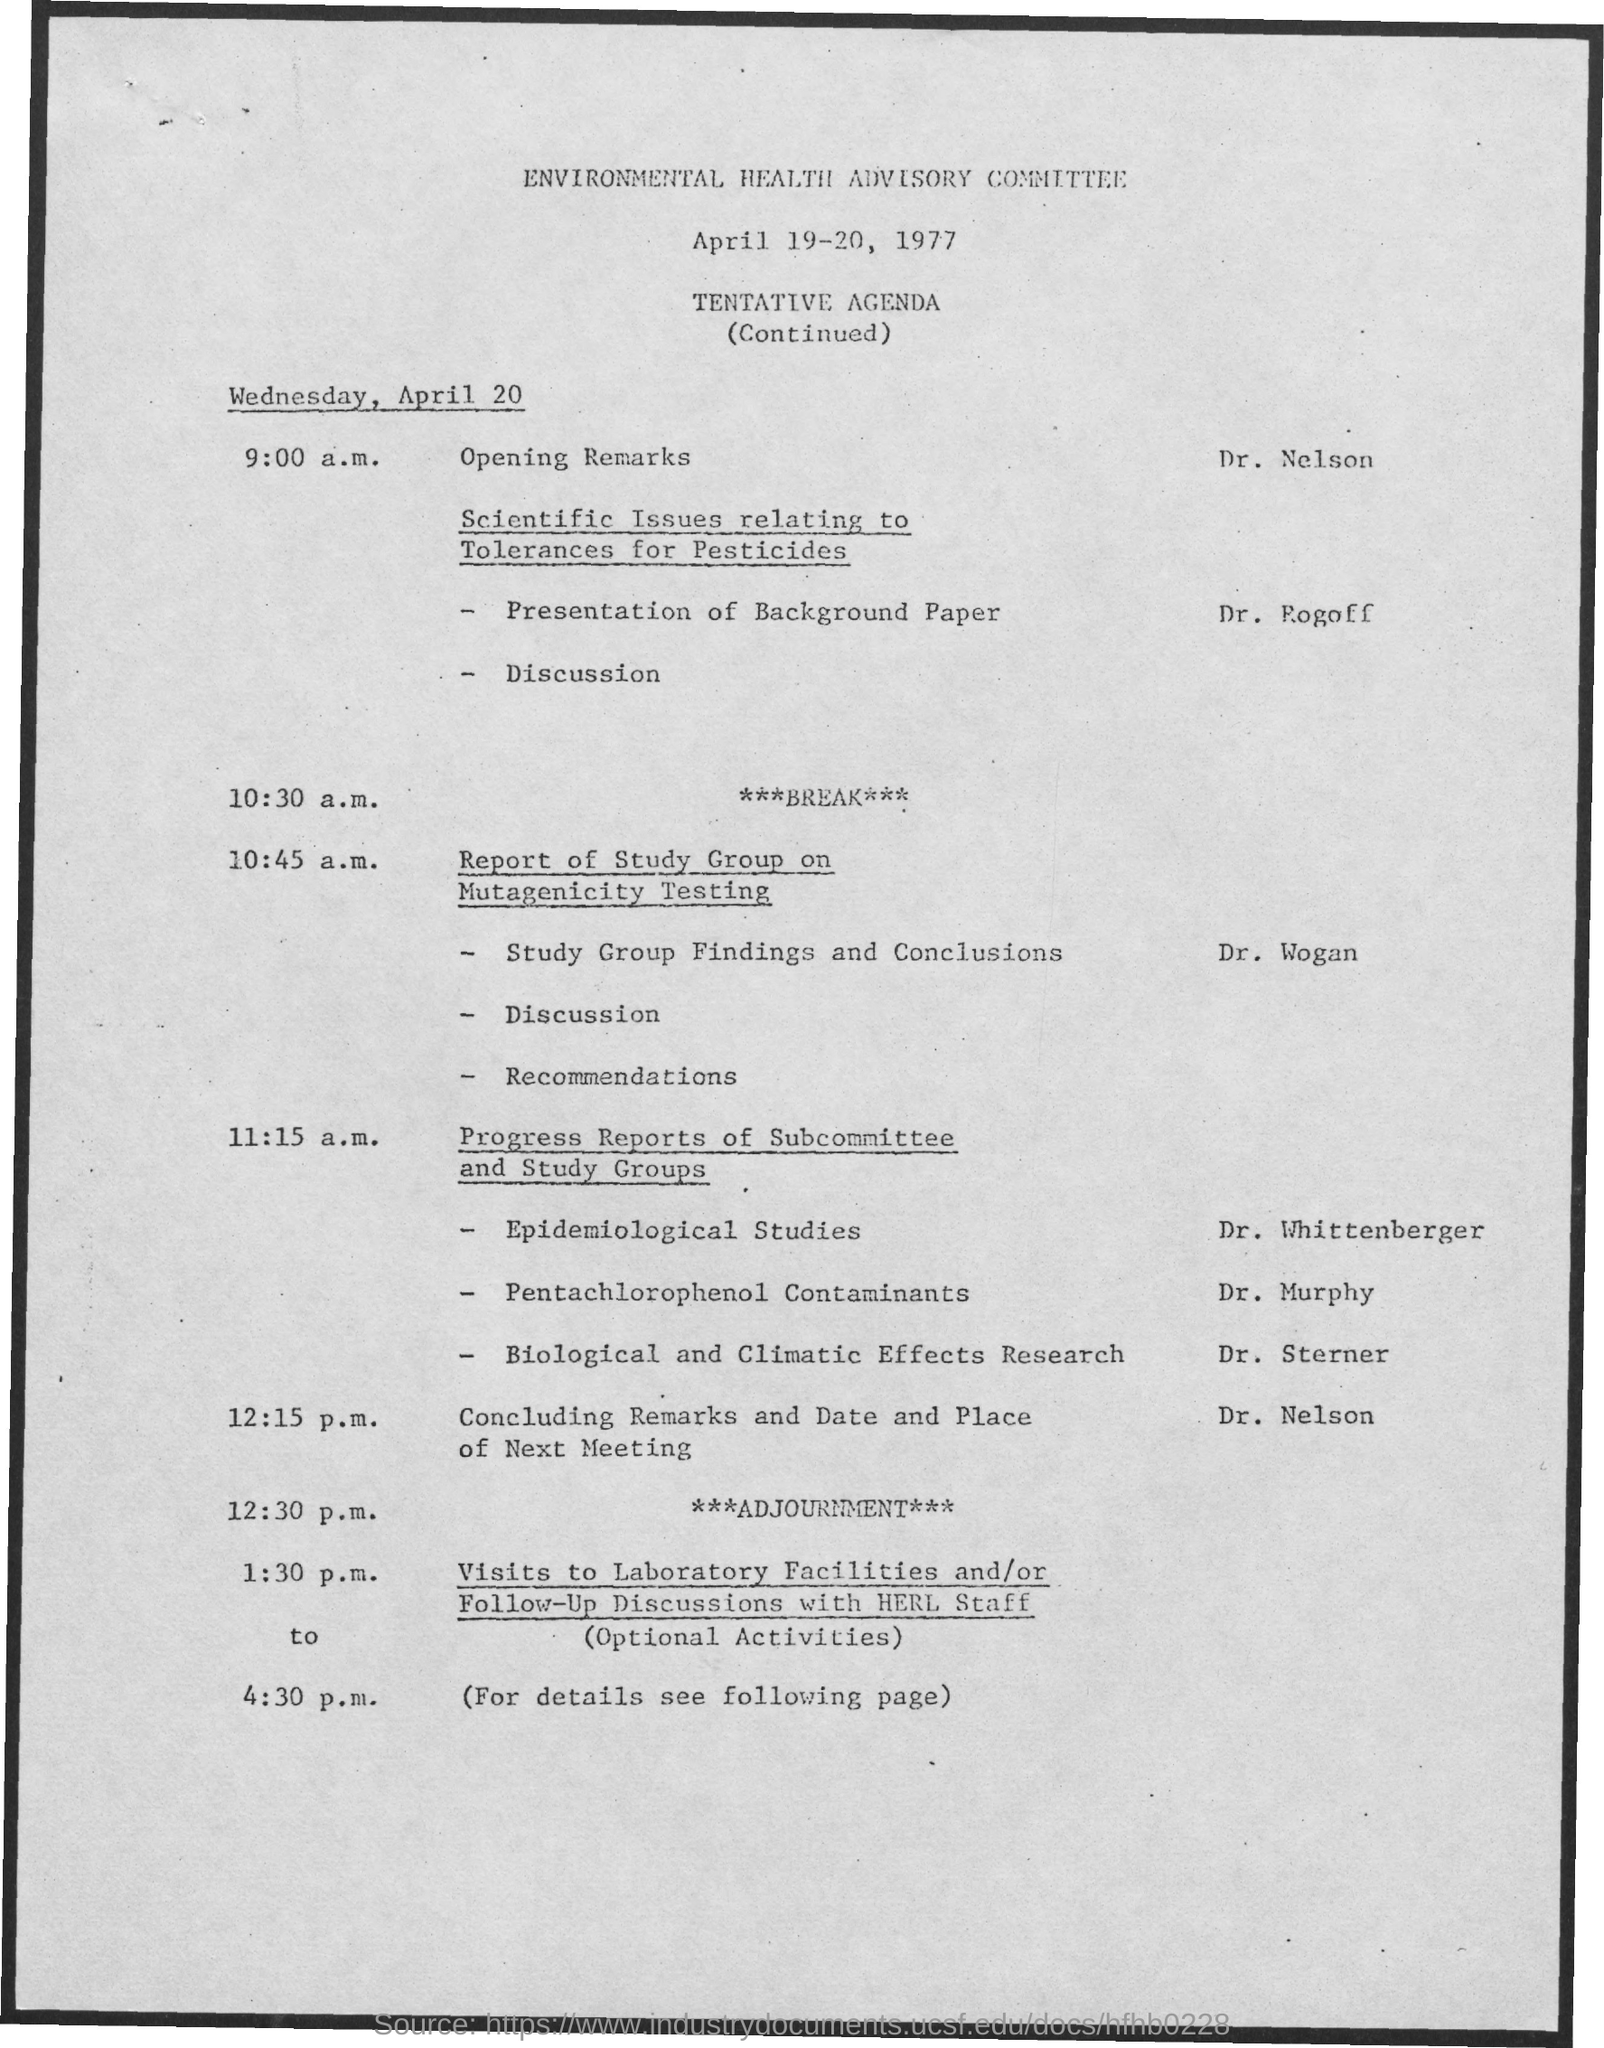What is the name of the committee mentioned?
Keep it short and to the point. Environmental health advisory committee. What is the date mentioned in the given page ?
Give a very brief answer. April 19-20 , 1977. What is the schedule at the time of 9:00 a.m. on wednesday , april 20?
Your answer should be compact. Opening remarks. What is the schedule at the time of 10:30 a.m. on april 20?
Provide a succinct answer. ***BREAK***. 